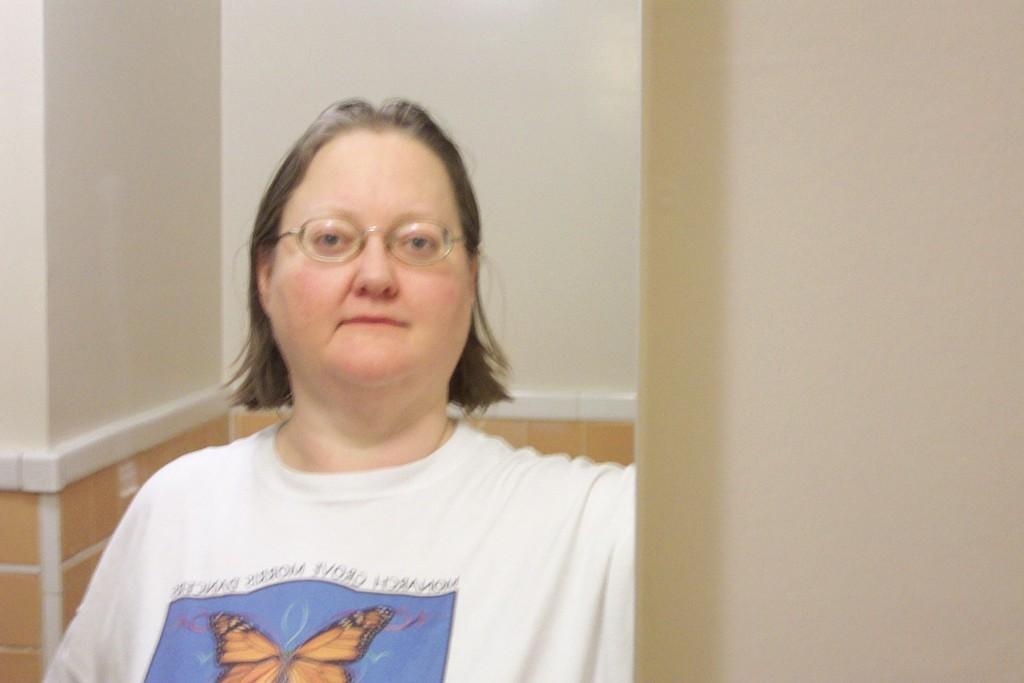Please provide a concise description of this image. in this picture I can see a woman. She wore a white color t-shirt and she wore spectacles and a wall on the back. 